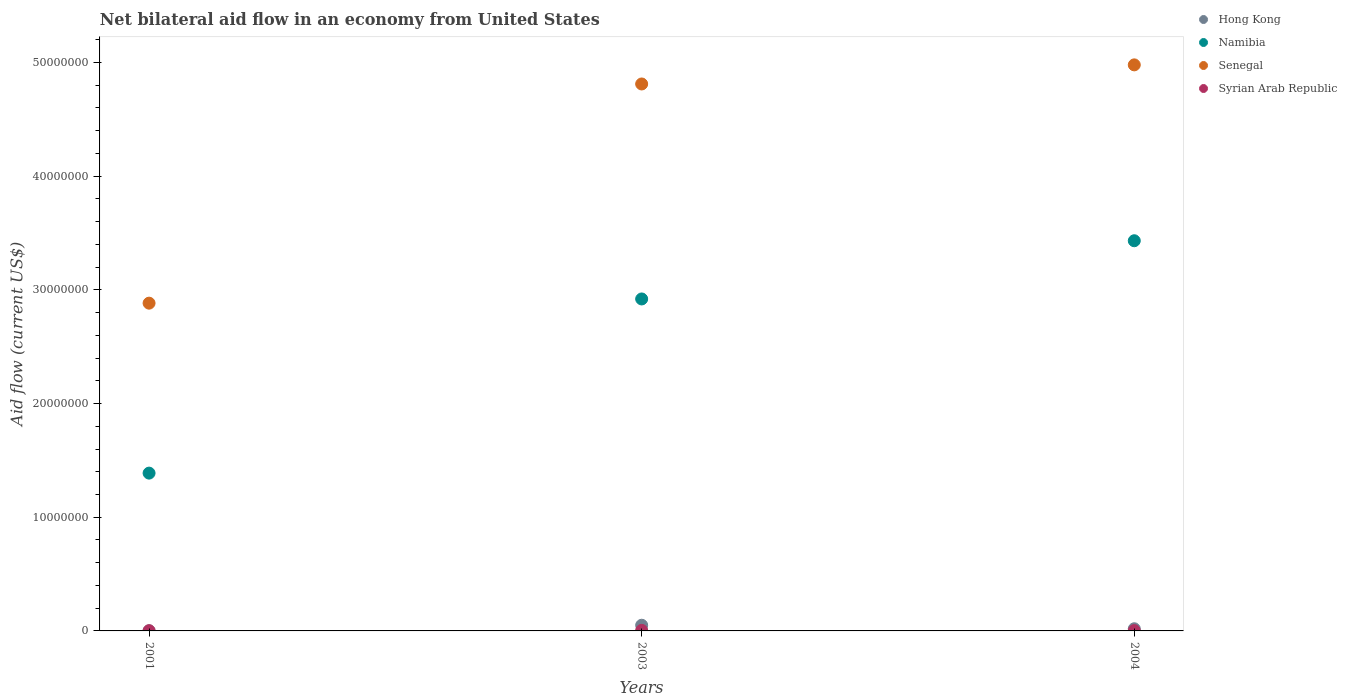How many different coloured dotlines are there?
Provide a short and direct response. 4. Is the number of dotlines equal to the number of legend labels?
Provide a short and direct response. Yes. What is the net bilateral aid flow in Senegal in 2004?
Make the answer very short. 4.98e+07. Across all years, what is the maximum net bilateral aid flow in Syrian Arab Republic?
Provide a short and direct response. 5.00e+04. Across all years, what is the minimum net bilateral aid flow in Senegal?
Offer a very short reply. 2.88e+07. In which year was the net bilateral aid flow in Senegal maximum?
Your response must be concise. 2004. In which year was the net bilateral aid flow in Senegal minimum?
Provide a short and direct response. 2001. What is the total net bilateral aid flow in Namibia in the graph?
Make the answer very short. 7.74e+07. What is the difference between the net bilateral aid flow in Namibia in 2003 and that in 2004?
Make the answer very short. -5.12e+06. What is the difference between the net bilateral aid flow in Syrian Arab Republic in 2004 and the net bilateral aid flow in Hong Kong in 2003?
Give a very brief answer. -4.70e+05. What is the average net bilateral aid flow in Hong Kong per year?
Keep it short and to the point. 2.33e+05. In the year 2001, what is the difference between the net bilateral aid flow in Hong Kong and net bilateral aid flow in Namibia?
Your answer should be very brief. -1.39e+07. What is the ratio of the net bilateral aid flow in Senegal in 2001 to that in 2004?
Provide a succinct answer. 0.58. Is the difference between the net bilateral aid flow in Hong Kong in 2003 and 2004 greater than the difference between the net bilateral aid flow in Namibia in 2003 and 2004?
Your answer should be compact. Yes. What is the difference between the highest and the second highest net bilateral aid flow in Namibia?
Your answer should be compact. 5.12e+06. What is the difference between the highest and the lowest net bilateral aid flow in Syrian Arab Republic?
Make the answer very short. 3.00e+04. In how many years, is the net bilateral aid flow in Senegal greater than the average net bilateral aid flow in Senegal taken over all years?
Provide a succinct answer. 2. Is it the case that in every year, the sum of the net bilateral aid flow in Syrian Arab Republic and net bilateral aid flow in Namibia  is greater than the net bilateral aid flow in Hong Kong?
Keep it short and to the point. Yes. Does the net bilateral aid flow in Syrian Arab Republic monotonically increase over the years?
Provide a short and direct response. No. Is the net bilateral aid flow in Syrian Arab Republic strictly greater than the net bilateral aid flow in Senegal over the years?
Offer a terse response. No. Is the net bilateral aid flow in Senegal strictly less than the net bilateral aid flow in Syrian Arab Republic over the years?
Ensure brevity in your answer.  No. How many dotlines are there?
Give a very brief answer. 4. How many years are there in the graph?
Offer a terse response. 3. Does the graph contain any zero values?
Offer a terse response. No. Does the graph contain grids?
Your answer should be compact. No. How many legend labels are there?
Provide a succinct answer. 4. What is the title of the graph?
Ensure brevity in your answer.  Net bilateral aid flow in an economy from United States. Does "Guinea-Bissau" appear as one of the legend labels in the graph?
Ensure brevity in your answer.  No. What is the label or title of the X-axis?
Provide a short and direct response. Years. What is the Aid flow (current US$) in Namibia in 2001?
Your answer should be compact. 1.39e+07. What is the Aid flow (current US$) of Senegal in 2001?
Provide a short and direct response. 2.88e+07. What is the Aid flow (current US$) of Namibia in 2003?
Offer a terse response. 2.92e+07. What is the Aid flow (current US$) in Senegal in 2003?
Offer a very short reply. 4.81e+07. What is the Aid flow (current US$) in Namibia in 2004?
Your answer should be very brief. 3.43e+07. What is the Aid flow (current US$) of Senegal in 2004?
Offer a terse response. 4.98e+07. What is the Aid flow (current US$) in Syrian Arab Republic in 2004?
Offer a terse response. 3.00e+04. Across all years, what is the maximum Aid flow (current US$) in Namibia?
Offer a very short reply. 3.43e+07. Across all years, what is the maximum Aid flow (current US$) of Senegal?
Make the answer very short. 4.98e+07. Across all years, what is the maximum Aid flow (current US$) of Syrian Arab Republic?
Provide a succinct answer. 5.00e+04. Across all years, what is the minimum Aid flow (current US$) of Namibia?
Your response must be concise. 1.39e+07. Across all years, what is the minimum Aid flow (current US$) of Senegal?
Your response must be concise. 2.88e+07. Across all years, what is the minimum Aid flow (current US$) of Syrian Arab Republic?
Offer a terse response. 2.00e+04. What is the total Aid flow (current US$) of Namibia in the graph?
Make the answer very short. 7.74e+07. What is the total Aid flow (current US$) of Senegal in the graph?
Give a very brief answer. 1.27e+08. What is the total Aid flow (current US$) in Syrian Arab Republic in the graph?
Keep it short and to the point. 1.00e+05. What is the difference between the Aid flow (current US$) of Hong Kong in 2001 and that in 2003?
Ensure brevity in your answer.  -4.90e+05. What is the difference between the Aid flow (current US$) of Namibia in 2001 and that in 2003?
Your response must be concise. -1.53e+07. What is the difference between the Aid flow (current US$) of Senegal in 2001 and that in 2003?
Keep it short and to the point. -1.93e+07. What is the difference between the Aid flow (current US$) in Syrian Arab Republic in 2001 and that in 2003?
Make the answer very short. -3.00e+04. What is the difference between the Aid flow (current US$) in Hong Kong in 2001 and that in 2004?
Your answer should be compact. -1.80e+05. What is the difference between the Aid flow (current US$) in Namibia in 2001 and that in 2004?
Keep it short and to the point. -2.04e+07. What is the difference between the Aid flow (current US$) in Senegal in 2001 and that in 2004?
Make the answer very short. -2.10e+07. What is the difference between the Aid flow (current US$) of Syrian Arab Republic in 2001 and that in 2004?
Your response must be concise. -10000. What is the difference between the Aid flow (current US$) in Hong Kong in 2003 and that in 2004?
Ensure brevity in your answer.  3.10e+05. What is the difference between the Aid flow (current US$) of Namibia in 2003 and that in 2004?
Make the answer very short. -5.12e+06. What is the difference between the Aid flow (current US$) of Senegal in 2003 and that in 2004?
Provide a short and direct response. -1.68e+06. What is the difference between the Aid flow (current US$) in Hong Kong in 2001 and the Aid flow (current US$) in Namibia in 2003?
Keep it short and to the point. -2.92e+07. What is the difference between the Aid flow (current US$) in Hong Kong in 2001 and the Aid flow (current US$) in Senegal in 2003?
Keep it short and to the point. -4.81e+07. What is the difference between the Aid flow (current US$) of Namibia in 2001 and the Aid flow (current US$) of Senegal in 2003?
Offer a terse response. -3.42e+07. What is the difference between the Aid flow (current US$) of Namibia in 2001 and the Aid flow (current US$) of Syrian Arab Republic in 2003?
Your answer should be very brief. 1.38e+07. What is the difference between the Aid flow (current US$) in Senegal in 2001 and the Aid flow (current US$) in Syrian Arab Republic in 2003?
Provide a succinct answer. 2.88e+07. What is the difference between the Aid flow (current US$) in Hong Kong in 2001 and the Aid flow (current US$) in Namibia in 2004?
Make the answer very short. -3.43e+07. What is the difference between the Aid flow (current US$) of Hong Kong in 2001 and the Aid flow (current US$) of Senegal in 2004?
Give a very brief answer. -4.98e+07. What is the difference between the Aid flow (current US$) in Namibia in 2001 and the Aid flow (current US$) in Senegal in 2004?
Keep it short and to the point. -3.59e+07. What is the difference between the Aid flow (current US$) in Namibia in 2001 and the Aid flow (current US$) in Syrian Arab Republic in 2004?
Offer a very short reply. 1.38e+07. What is the difference between the Aid flow (current US$) in Senegal in 2001 and the Aid flow (current US$) in Syrian Arab Republic in 2004?
Your answer should be very brief. 2.88e+07. What is the difference between the Aid flow (current US$) of Hong Kong in 2003 and the Aid flow (current US$) of Namibia in 2004?
Provide a succinct answer. -3.38e+07. What is the difference between the Aid flow (current US$) in Hong Kong in 2003 and the Aid flow (current US$) in Senegal in 2004?
Your answer should be compact. -4.93e+07. What is the difference between the Aid flow (current US$) of Hong Kong in 2003 and the Aid flow (current US$) of Syrian Arab Republic in 2004?
Ensure brevity in your answer.  4.70e+05. What is the difference between the Aid flow (current US$) of Namibia in 2003 and the Aid flow (current US$) of Senegal in 2004?
Your answer should be compact. -2.06e+07. What is the difference between the Aid flow (current US$) in Namibia in 2003 and the Aid flow (current US$) in Syrian Arab Republic in 2004?
Your response must be concise. 2.92e+07. What is the difference between the Aid flow (current US$) of Senegal in 2003 and the Aid flow (current US$) of Syrian Arab Republic in 2004?
Give a very brief answer. 4.81e+07. What is the average Aid flow (current US$) of Hong Kong per year?
Offer a very short reply. 2.33e+05. What is the average Aid flow (current US$) of Namibia per year?
Your answer should be very brief. 2.58e+07. What is the average Aid flow (current US$) of Senegal per year?
Your answer should be compact. 4.22e+07. What is the average Aid flow (current US$) in Syrian Arab Republic per year?
Provide a succinct answer. 3.33e+04. In the year 2001, what is the difference between the Aid flow (current US$) of Hong Kong and Aid flow (current US$) of Namibia?
Give a very brief answer. -1.39e+07. In the year 2001, what is the difference between the Aid flow (current US$) of Hong Kong and Aid flow (current US$) of Senegal?
Make the answer very short. -2.88e+07. In the year 2001, what is the difference between the Aid flow (current US$) of Namibia and Aid flow (current US$) of Senegal?
Your answer should be compact. -1.50e+07. In the year 2001, what is the difference between the Aid flow (current US$) of Namibia and Aid flow (current US$) of Syrian Arab Republic?
Offer a terse response. 1.39e+07. In the year 2001, what is the difference between the Aid flow (current US$) of Senegal and Aid flow (current US$) of Syrian Arab Republic?
Your answer should be very brief. 2.88e+07. In the year 2003, what is the difference between the Aid flow (current US$) of Hong Kong and Aid flow (current US$) of Namibia?
Provide a succinct answer. -2.87e+07. In the year 2003, what is the difference between the Aid flow (current US$) of Hong Kong and Aid flow (current US$) of Senegal?
Give a very brief answer. -4.76e+07. In the year 2003, what is the difference between the Aid flow (current US$) in Hong Kong and Aid flow (current US$) in Syrian Arab Republic?
Offer a very short reply. 4.50e+05. In the year 2003, what is the difference between the Aid flow (current US$) in Namibia and Aid flow (current US$) in Senegal?
Your answer should be very brief. -1.89e+07. In the year 2003, what is the difference between the Aid flow (current US$) in Namibia and Aid flow (current US$) in Syrian Arab Republic?
Offer a terse response. 2.92e+07. In the year 2003, what is the difference between the Aid flow (current US$) of Senegal and Aid flow (current US$) of Syrian Arab Republic?
Make the answer very short. 4.81e+07. In the year 2004, what is the difference between the Aid flow (current US$) in Hong Kong and Aid flow (current US$) in Namibia?
Offer a very short reply. -3.41e+07. In the year 2004, what is the difference between the Aid flow (current US$) in Hong Kong and Aid flow (current US$) in Senegal?
Make the answer very short. -4.96e+07. In the year 2004, what is the difference between the Aid flow (current US$) of Namibia and Aid flow (current US$) of Senegal?
Give a very brief answer. -1.55e+07. In the year 2004, what is the difference between the Aid flow (current US$) of Namibia and Aid flow (current US$) of Syrian Arab Republic?
Make the answer very short. 3.43e+07. In the year 2004, what is the difference between the Aid flow (current US$) in Senegal and Aid flow (current US$) in Syrian Arab Republic?
Offer a terse response. 4.98e+07. What is the ratio of the Aid flow (current US$) of Hong Kong in 2001 to that in 2003?
Your response must be concise. 0.02. What is the ratio of the Aid flow (current US$) of Namibia in 2001 to that in 2003?
Offer a very short reply. 0.48. What is the ratio of the Aid flow (current US$) of Senegal in 2001 to that in 2003?
Offer a terse response. 0.6. What is the ratio of the Aid flow (current US$) of Hong Kong in 2001 to that in 2004?
Provide a short and direct response. 0.05. What is the ratio of the Aid flow (current US$) of Namibia in 2001 to that in 2004?
Offer a terse response. 0.4. What is the ratio of the Aid flow (current US$) of Senegal in 2001 to that in 2004?
Your response must be concise. 0.58. What is the ratio of the Aid flow (current US$) of Hong Kong in 2003 to that in 2004?
Your response must be concise. 2.63. What is the ratio of the Aid flow (current US$) of Namibia in 2003 to that in 2004?
Make the answer very short. 0.85. What is the ratio of the Aid flow (current US$) in Senegal in 2003 to that in 2004?
Your response must be concise. 0.97. What is the ratio of the Aid flow (current US$) in Syrian Arab Republic in 2003 to that in 2004?
Provide a short and direct response. 1.67. What is the difference between the highest and the second highest Aid flow (current US$) of Namibia?
Offer a very short reply. 5.12e+06. What is the difference between the highest and the second highest Aid flow (current US$) in Senegal?
Keep it short and to the point. 1.68e+06. What is the difference between the highest and the second highest Aid flow (current US$) in Syrian Arab Republic?
Ensure brevity in your answer.  2.00e+04. What is the difference between the highest and the lowest Aid flow (current US$) in Hong Kong?
Your answer should be very brief. 4.90e+05. What is the difference between the highest and the lowest Aid flow (current US$) in Namibia?
Offer a very short reply. 2.04e+07. What is the difference between the highest and the lowest Aid flow (current US$) of Senegal?
Offer a terse response. 2.10e+07. 